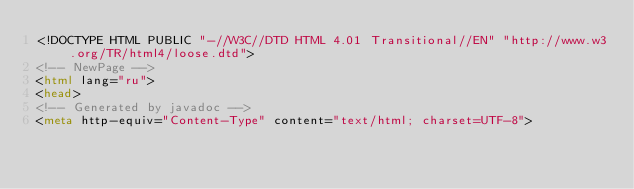Convert code to text. <code><loc_0><loc_0><loc_500><loc_500><_HTML_><!DOCTYPE HTML PUBLIC "-//W3C//DTD HTML 4.01 Transitional//EN" "http://www.w3.org/TR/html4/loose.dtd">
<!-- NewPage -->
<html lang="ru">
<head>
<!-- Generated by javadoc -->
<meta http-equiv="Content-Type" content="text/html; charset=UTF-8"></code> 